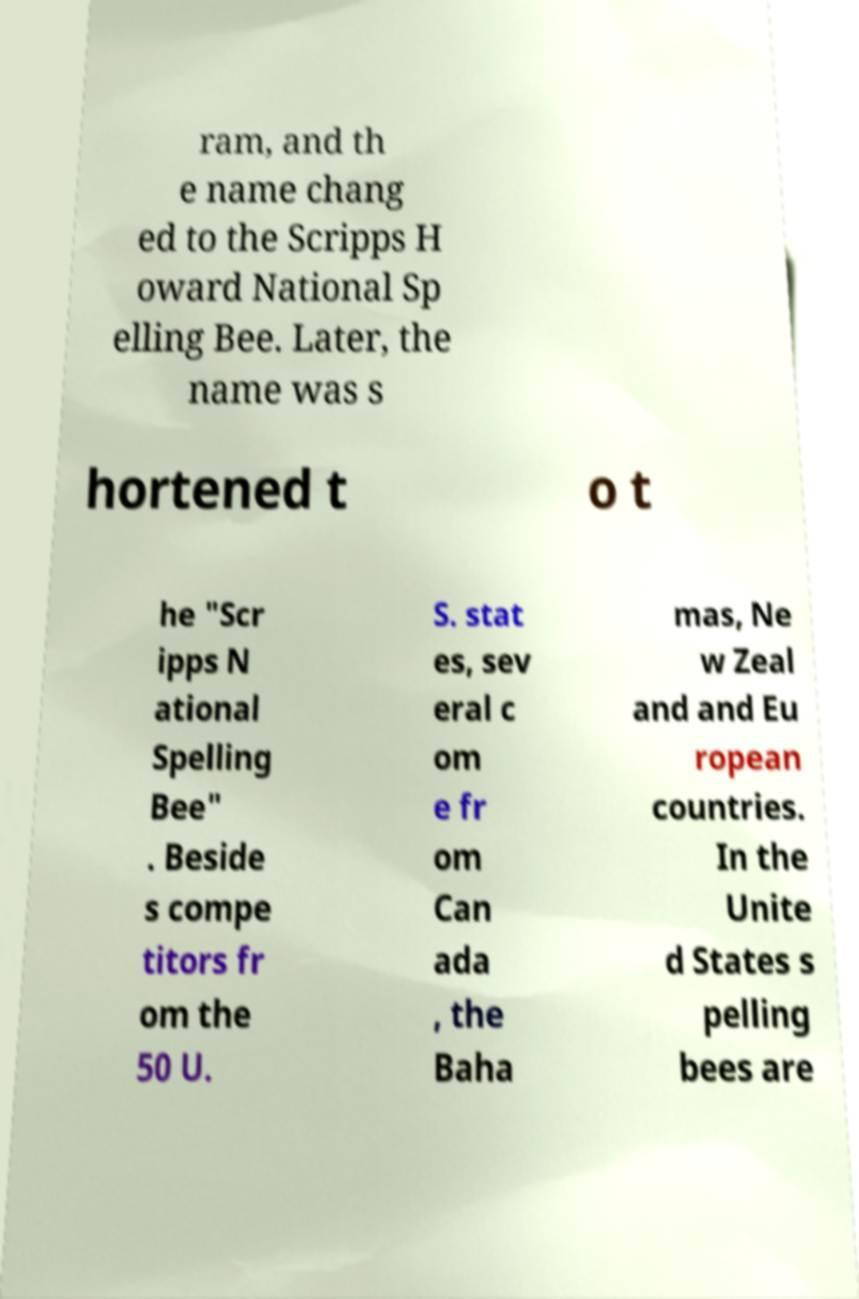Can you read and provide the text displayed in the image?This photo seems to have some interesting text. Can you extract and type it out for me? ram, and th e name chang ed to the Scripps H oward National Sp elling Bee. Later, the name was s hortened t o t he "Scr ipps N ational Spelling Bee" . Beside s compe titors fr om the 50 U. S. stat es, sev eral c om e fr om Can ada , the Baha mas, Ne w Zeal and and Eu ropean countries. In the Unite d States s pelling bees are 